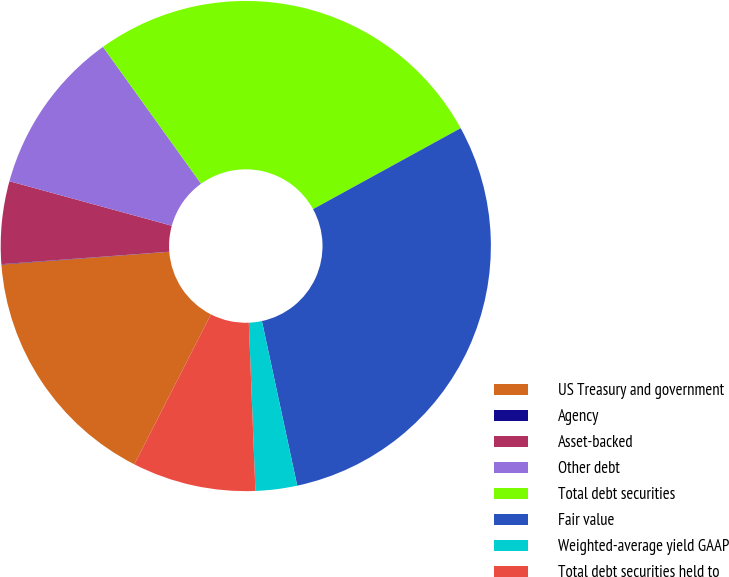<chart> <loc_0><loc_0><loc_500><loc_500><pie_chart><fcel>US Treasury and government<fcel>Agency<fcel>Asset-backed<fcel>Other debt<fcel>Total debt securities<fcel>Fair value<fcel>Weighted-average yield GAAP<fcel>Total debt securities held to<nl><fcel>16.28%<fcel>0.03%<fcel>5.44%<fcel>10.84%<fcel>26.92%<fcel>29.62%<fcel>2.74%<fcel>8.14%<nl></chart> 